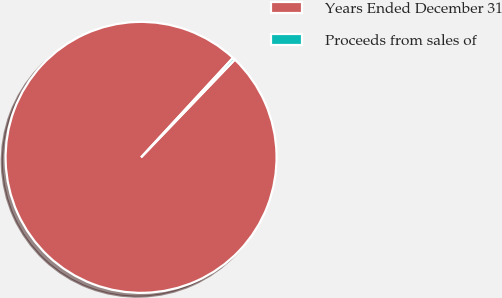Convert chart to OTSL. <chart><loc_0><loc_0><loc_500><loc_500><pie_chart><fcel>Years Ended December 31<fcel>Proceeds from sales of<nl><fcel>99.7%<fcel>0.3%<nl></chart> 